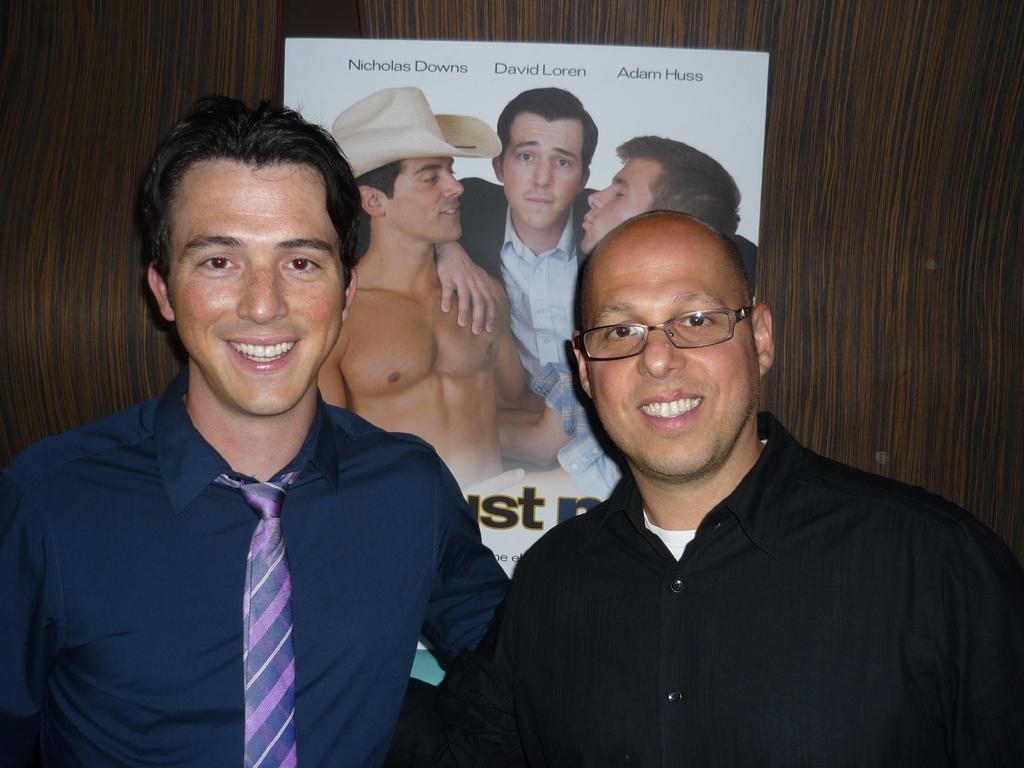How would you summarize this image in a sentence or two? In this picture in the front of there are persons smiling. In the background there is a poster with some text and images on it. 